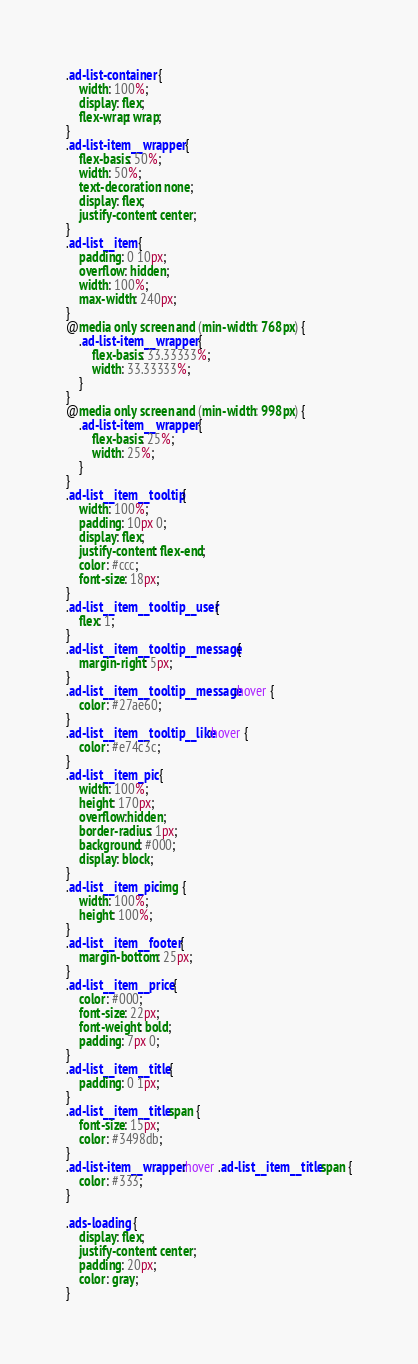<code> <loc_0><loc_0><loc_500><loc_500><_CSS_>.ad-list-container {
    width: 100%;
    display: flex;
    flex-wrap: wrap;
}
.ad-list-item__wrapper {
    flex-basis: 50%;
    width: 50%;
    text-decoration: none;
    display: flex;
    justify-content: center;
}
.ad-list__item {
    padding: 0 10px;
    overflow: hidden;
    width: 100%;
    max-width: 240px;
}
@media only screen and (min-width: 768px) {
    .ad-list-item__wrapper {
        flex-basis: 33.33333%;
        width: 33.33333%;
    }
}
@media only screen and (min-width: 998px) {
    .ad-list-item__wrapper {
        flex-basis: 25%;
        width: 25%;
    }
}
.ad-list__item__tooltip {
    width: 100%;
    padding: 10px 0;
    display: flex;
    justify-content: flex-end;
    color: #ccc;
    font-size: 18px;
}
.ad-list__item__tooltip__user {
    flex: 1;
}
.ad-list__item__tooltip__message {
    margin-right: 5px;
}
.ad-list__item__tooltip__message:hover {
    color: #27ae60;
}
.ad-list__item__tooltip__like:hover {
    color: #e74c3c;
}
.ad-list__item_pic {
    width: 100%;
    height: 170px;
    overflow:hidden;
    border-radius: 1px;
    background: #000;
    display: block;
}
.ad-list__item_pic img {
    width: 100%;
    height: 100%;
}
.ad-list__item__footer {
    margin-bottom: 25px;
}
.ad-list__item__price {
    color: #000;
    font-size: 22px;
    font-weight: bold;
    padding: 7px 0;
}
.ad-list__item__title {
    padding: 0 1px;
}
.ad-list__item__title span {
    font-size: 15px;
    color: #3498db;
}
.ad-list-item__wrapper:hover .ad-list__item__title span {
    color: #333;
}

.ads-loading {
    display: flex;
    justify-content: center;
    padding: 20px;
    color: gray;
}</code> 